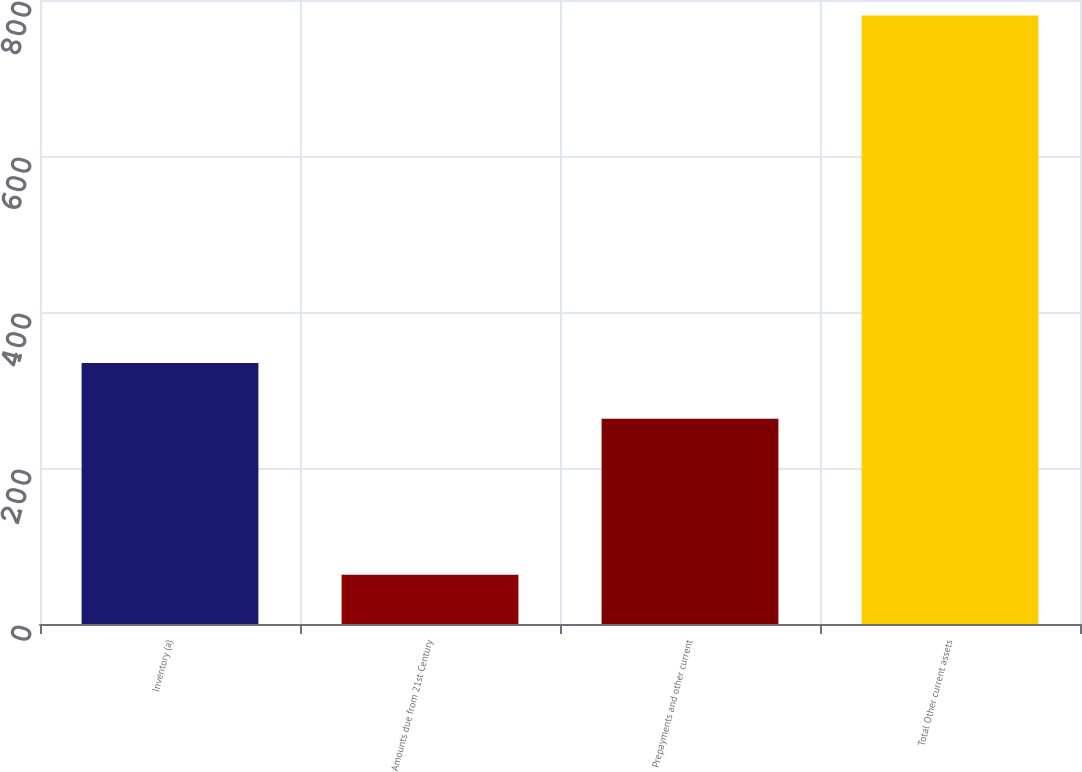Convert chart. <chart><loc_0><loc_0><loc_500><loc_500><bar_chart><fcel>Inventory (a)<fcel>Amounts due from 21st Century<fcel>Prepayments and other current<fcel>Total Other current assets<nl><fcel>334.7<fcel>63<fcel>263<fcel>780<nl></chart> 